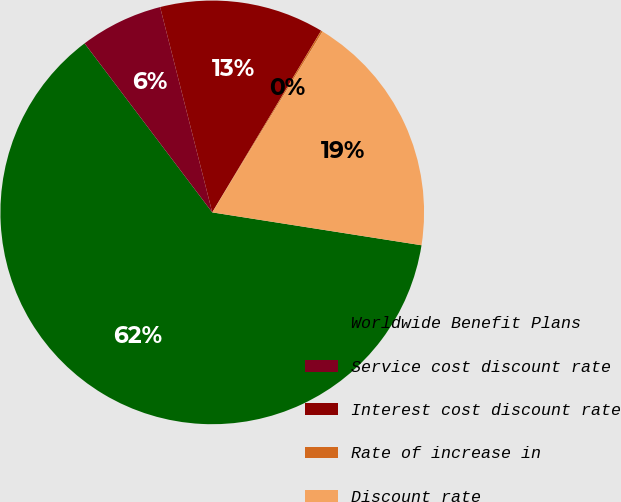<chart> <loc_0><loc_0><loc_500><loc_500><pie_chart><fcel>Worldwide Benefit Plans<fcel>Service cost discount rate<fcel>Interest cost discount rate<fcel>Rate of increase in<fcel>Discount rate<nl><fcel>62.23%<fcel>6.34%<fcel>12.55%<fcel>0.13%<fcel>18.76%<nl></chart> 